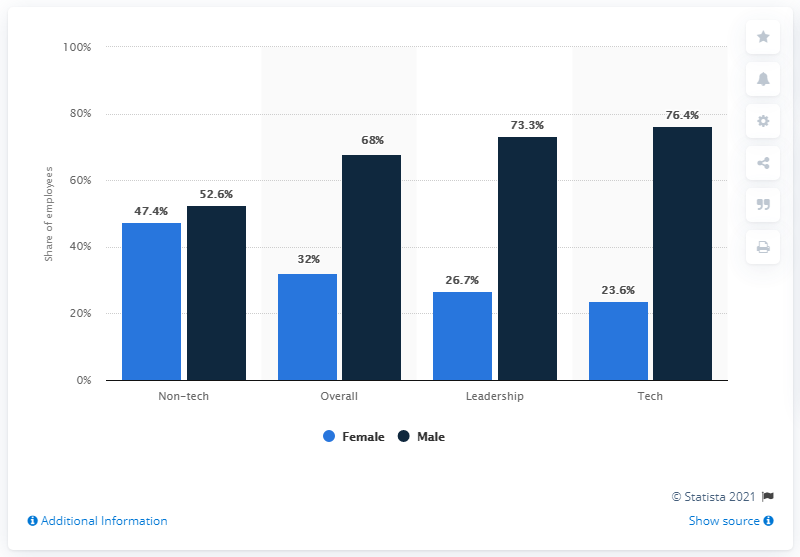Give some essential details in this illustration. The average of all the dark blue bars is 67.575... The difference between the highest percentage of female employees in all departments and the lowest percentage of female employees in all departments is 23.8%. 